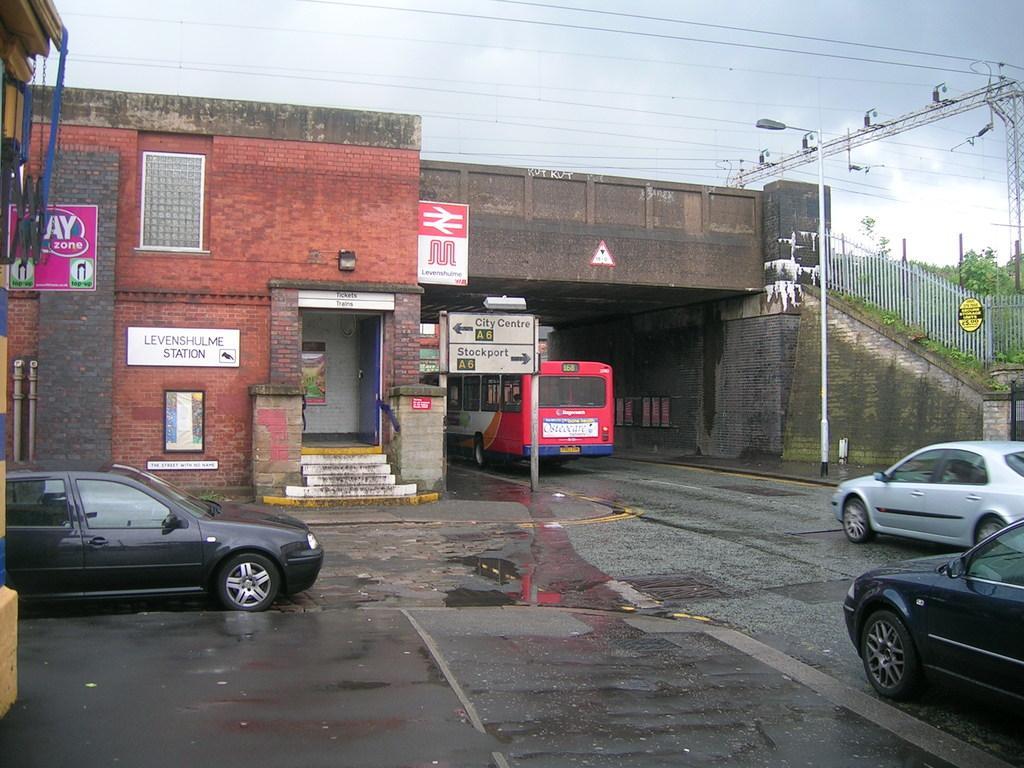Please provide a concise description of this image. In this image there is a road,a black car on the left of the image,a car towards the right side of the image,a street light,there is a pole,there is a sign board,there is a bus,there is a staircase,there is a sky,there are wires,there are plants. 